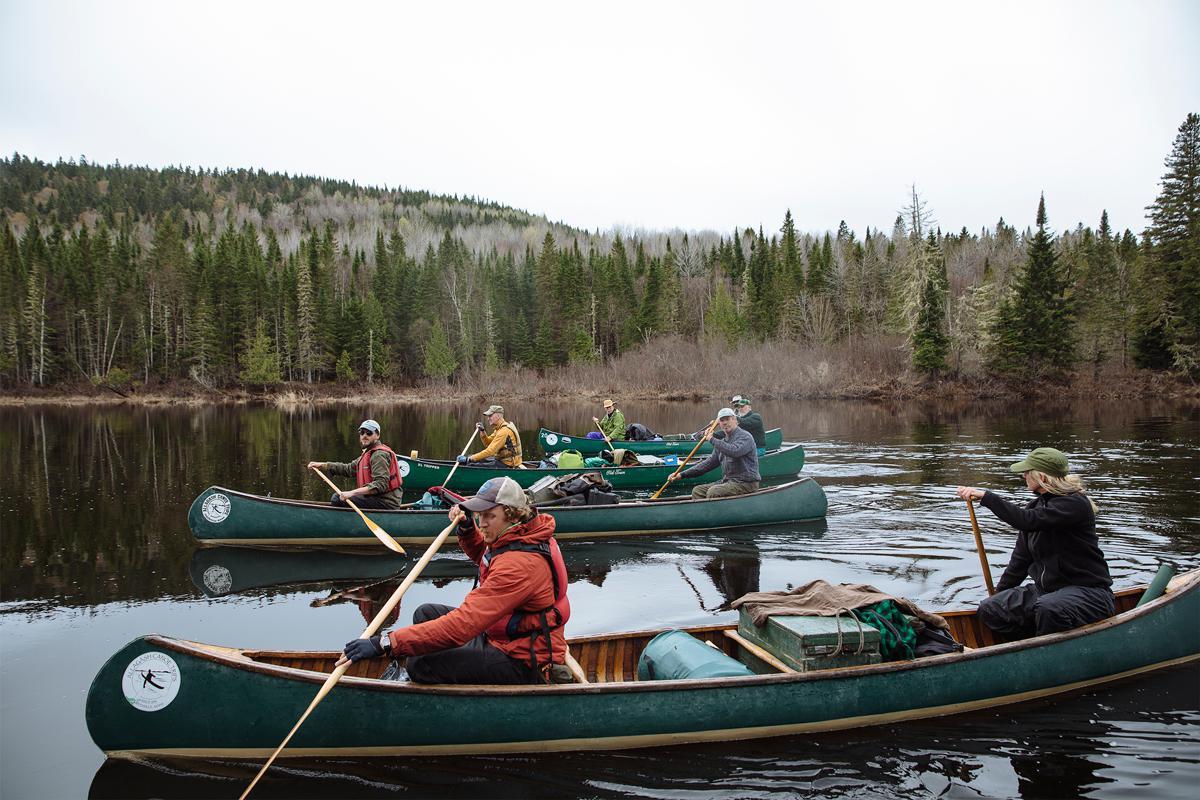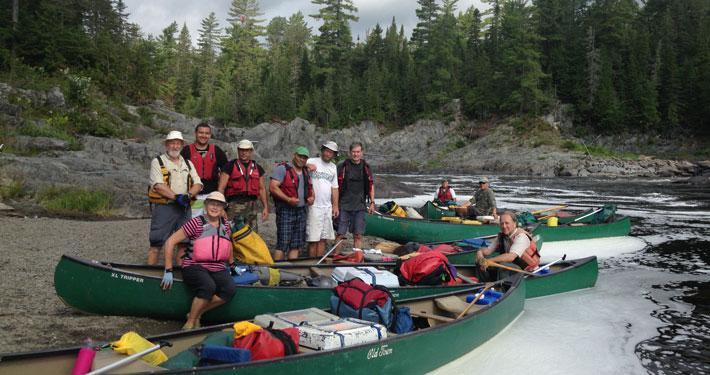The first image is the image on the left, the second image is the image on the right. Considering the images on both sides, is "A boat is floating in water." valid? Answer yes or no. Yes. The first image is the image on the left, the second image is the image on the right. For the images shown, is this caption "There are not human beings visible in at least one image." true? Answer yes or no. No. 